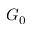Convert formula to latex. <formula><loc_0><loc_0><loc_500><loc_500>G _ { 0 }</formula> 